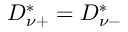Convert formula to latex. <formula><loc_0><loc_0><loc_500><loc_500>D _ { \nu + } ^ { * } = D _ { \nu - } ^ { * }</formula> 